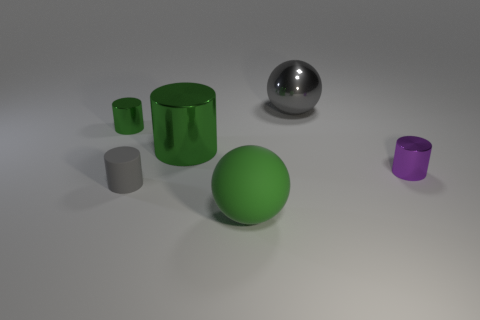Add 2 large shiny spheres. How many objects exist? 8 Subtract all spheres. How many objects are left? 4 Add 3 big green things. How many big green things are left? 5 Add 1 cyan cylinders. How many cyan cylinders exist? 1 Subtract 0 yellow cylinders. How many objects are left? 6 Subtract all large green matte objects. Subtract all green balls. How many objects are left? 4 